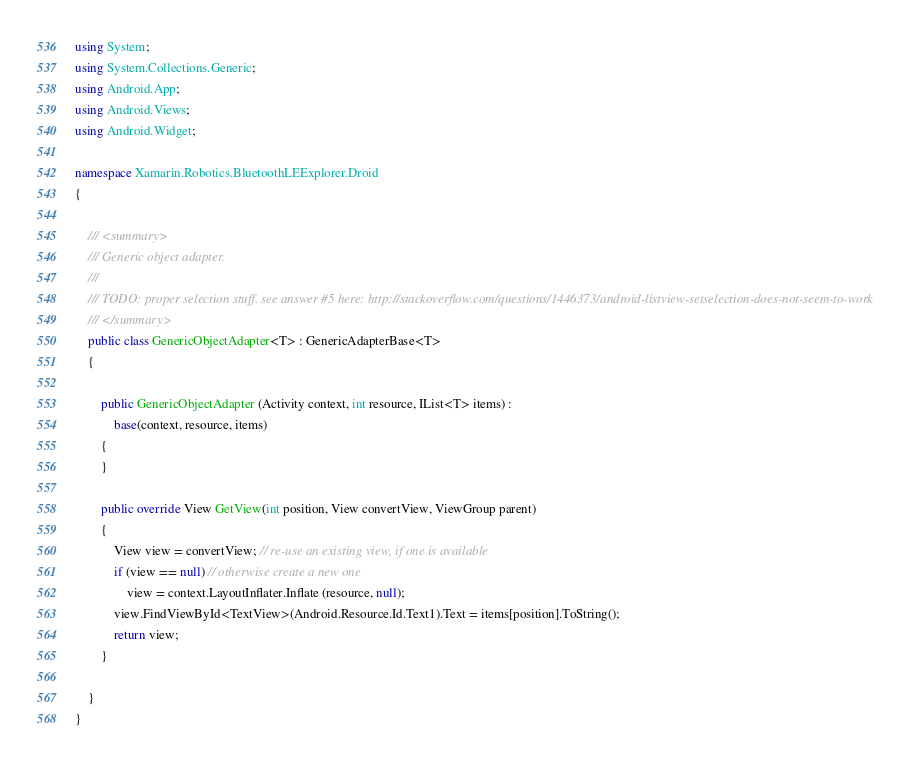<code> <loc_0><loc_0><loc_500><loc_500><_C#_>using System;
using System.Collections.Generic;
using Android.App;
using Android.Views;
using Android.Widget;

namespace Xamarin.Robotics.BluetoothLEExplorer.Droid
{

	/// <summary>
	/// Generic object adapter.
	/// 
	/// TODO: proper selection stuff. see answer #5 here: http://stackoverflow.com/questions/1446373/android-listview-setselection-does-not-seem-to-work
	/// </summary>
	public class GenericObjectAdapter<T> : GenericAdapterBase<T>
	{

		public GenericObjectAdapter (Activity context, int resource, IList<T> items) : 
			base(context, resource, items)
		{
		}

		public override View GetView(int position, View convertView, ViewGroup parent)
		{
			View view = convertView; // re-use an existing view, if one is available
			if (view == null) // otherwise create a new one
				view = context.LayoutInflater.Inflate (resource, null);
			view.FindViewById<TextView>(Android.Resource.Id.Text1).Text = items[position].ToString();
			return view;
		}

	}
}

</code> 